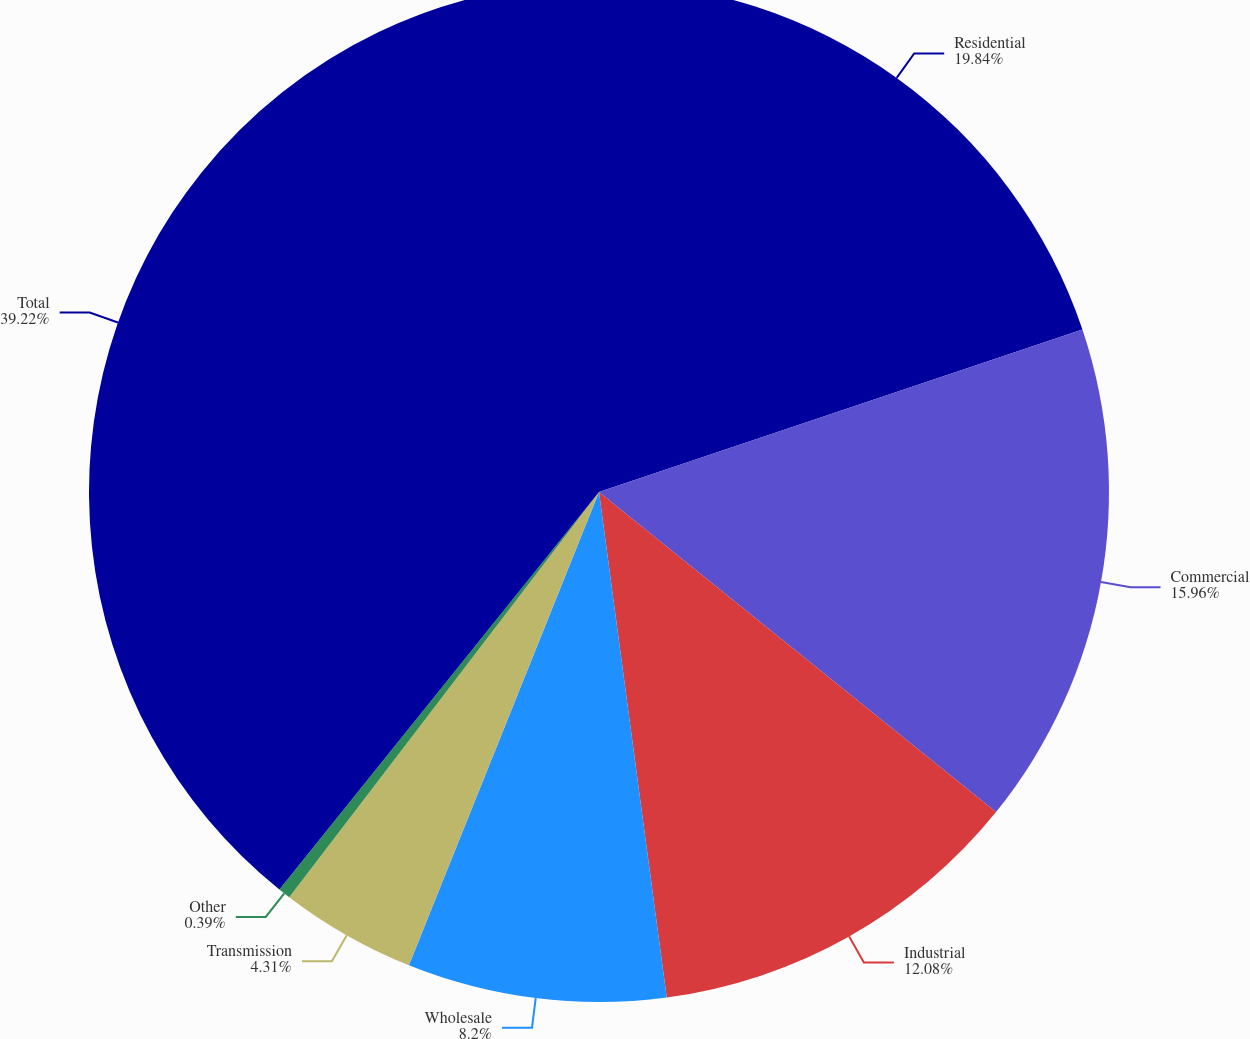Convert chart. <chart><loc_0><loc_0><loc_500><loc_500><pie_chart><fcel>Residential<fcel>Commercial<fcel>Industrial<fcel>Wholesale<fcel>Transmission<fcel>Other<fcel>Total<nl><fcel>19.84%<fcel>15.96%<fcel>12.08%<fcel>8.2%<fcel>4.31%<fcel>0.39%<fcel>39.22%<nl></chart> 